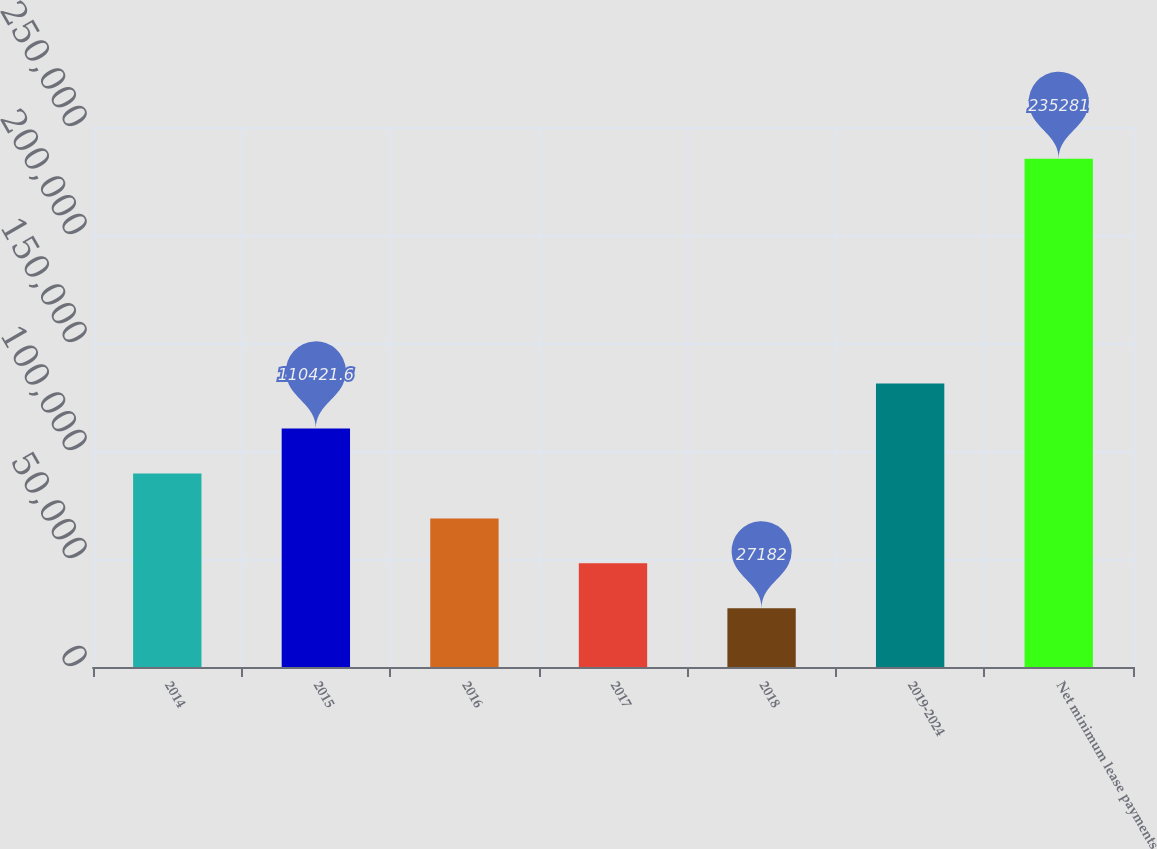<chart> <loc_0><loc_0><loc_500><loc_500><bar_chart><fcel>2014<fcel>2015<fcel>2016<fcel>2017<fcel>2018<fcel>2019-2024<fcel>Net minimum lease payments<nl><fcel>89611.7<fcel>110422<fcel>68801.8<fcel>47991.9<fcel>27182<fcel>131232<fcel>235281<nl></chart> 